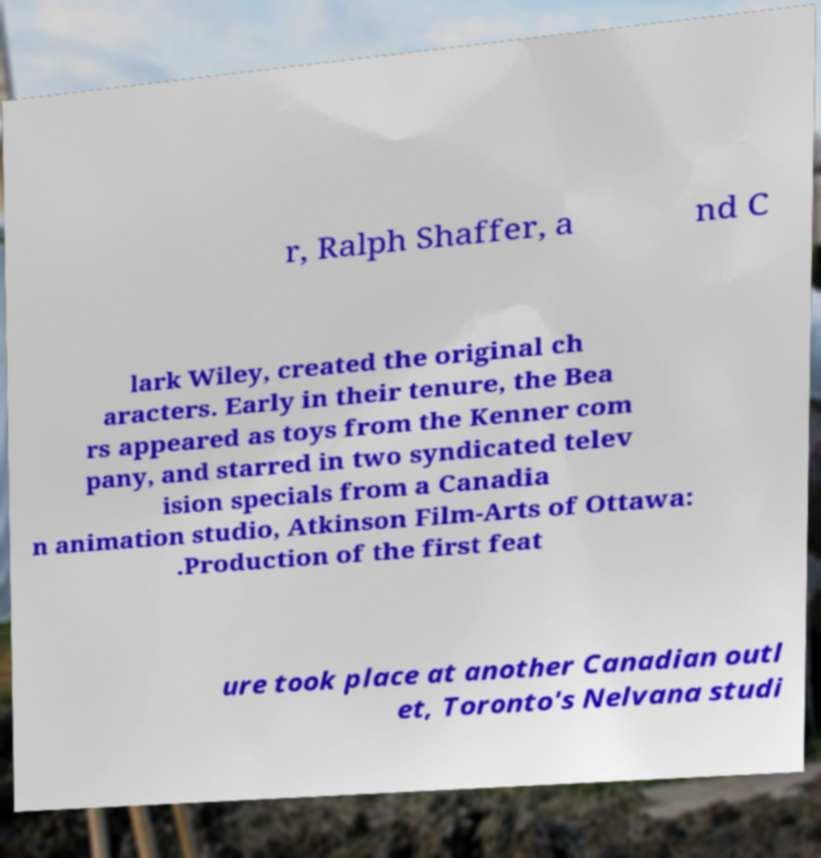Please identify and transcribe the text found in this image. r, Ralph Shaffer, a nd C lark Wiley, created the original ch aracters. Early in their tenure, the Bea rs appeared as toys from the Kenner com pany, and starred in two syndicated telev ision specials from a Canadia n animation studio, Atkinson Film-Arts of Ottawa: .Production of the first feat ure took place at another Canadian outl et, Toronto's Nelvana studi 